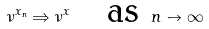Convert formula to latex. <formula><loc_0><loc_0><loc_500><loc_500>\nu ^ { x _ { n } } \Rightarrow \nu ^ { x } \quad \text {as } n \to \infty</formula> 